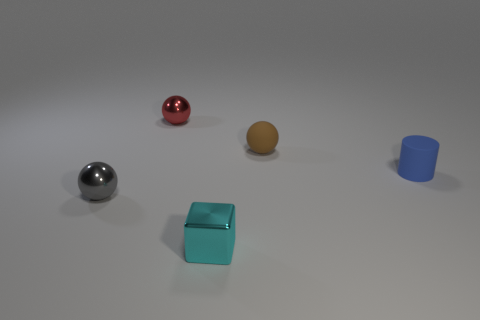Add 4 rubber cylinders. How many objects exist? 9 Subtract all spheres. How many objects are left? 2 Subtract 0 gray cylinders. How many objects are left? 5 Subtract all tiny gray metal things. Subtract all tiny brown rubber objects. How many objects are left? 3 Add 2 metal balls. How many metal balls are left? 4 Add 5 tiny red balls. How many tiny red balls exist? 6 